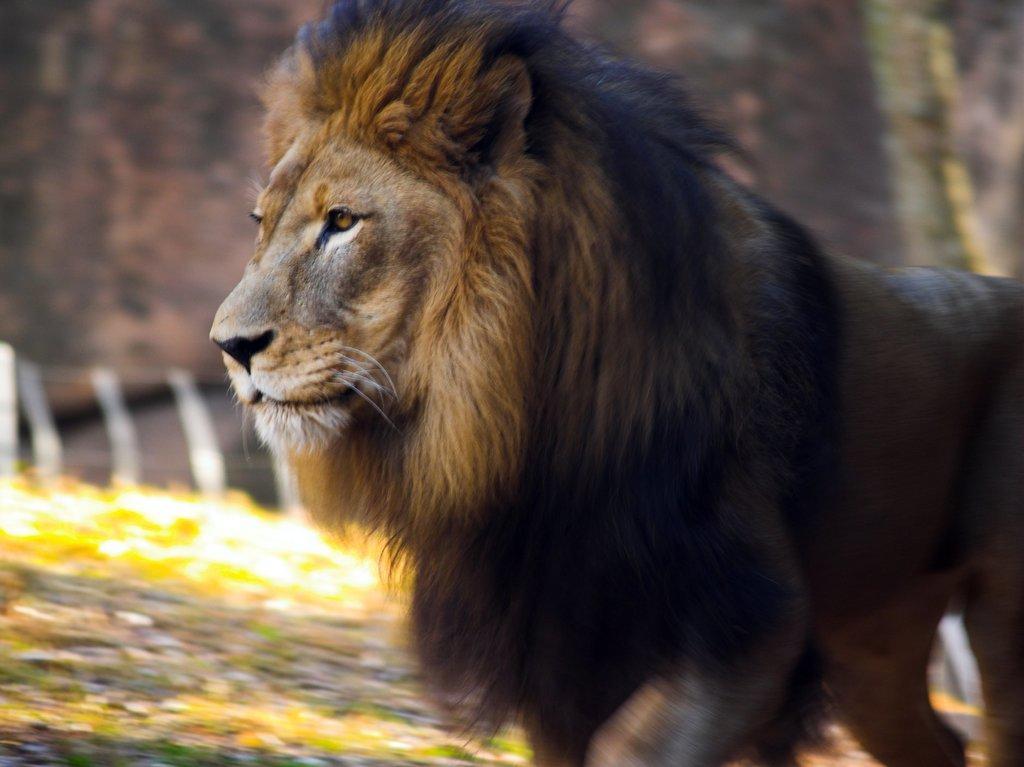How would you summarize this image in a sentence or two? In the picture we can see lion which is walking. 